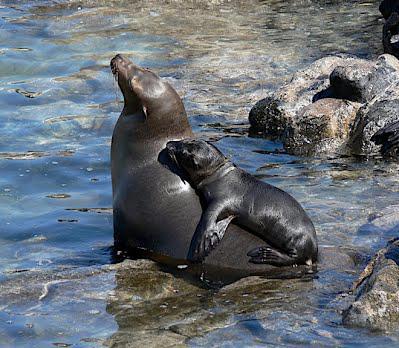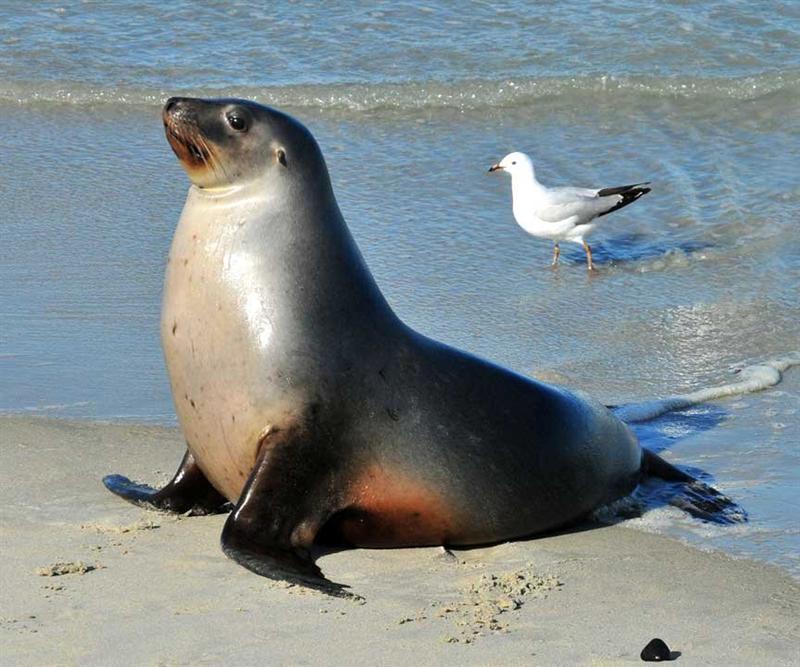The first image is the image on the left, the second image is the image on the right. Considering the images on both sides, is "One of the images contains a bird." valid? Answer yes or no. Yes. The first image is the image on the left, the second image is the image on the right. Evaluate the accuracy of this statement regarding the images: "There are several sea mammals in the picture on the right.". Is it true? Answer yes or no. No. 